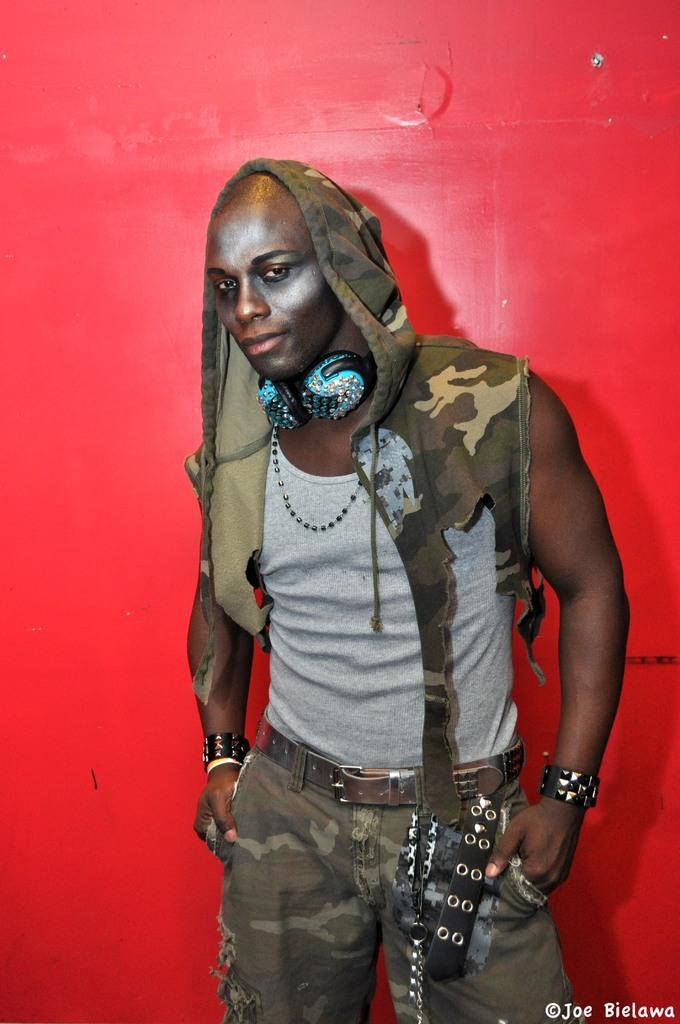What is the main subject of the image? The main subject of the image is a man. What is the man doing in the image? The man is standing in the image. What can be seen around the man's neck? The man is wearing a headset around his neck. What is visible in the background of the image? There is a wall in the background of the image. What is the appearance of the painting on the wall? The painting on the wall has a red color. What type of turkey is being cooked in the image? There is no turkey present in the image; it features a man standing with a headset around his neck and a red painting on the wall in the background. 